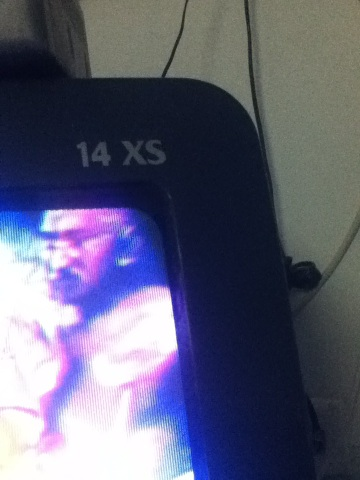Describe the surroundings where the TV or monitor is located. The surroundings of the TV or monitor include visible cables and a plain wall, suggesting a no-frills setup possibly in a living area or personal workspace. The focus is primarily on the device and its display, with minimal distractions from the background. What could be the significance of the text '14 XS' displayed on the device? The text '14 XS' likely denotes the model number or screen size specification of the television or monitor. It might be a product identifier used to distinguish this particular model from others in the sharegpt4v/same series or brand. Create a practical scenario involving this device in an average household. In a typical household, the '14 XS' television could be used for various everyday activities such as watching news, movies, and TV shows, connecting to gaming consoles for leisure, or as a display for computer-related work or study tasks. 